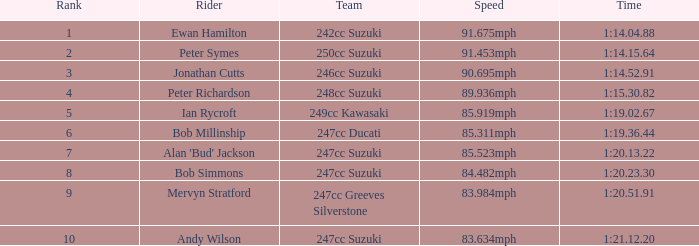88? 242cc Suzuki. 